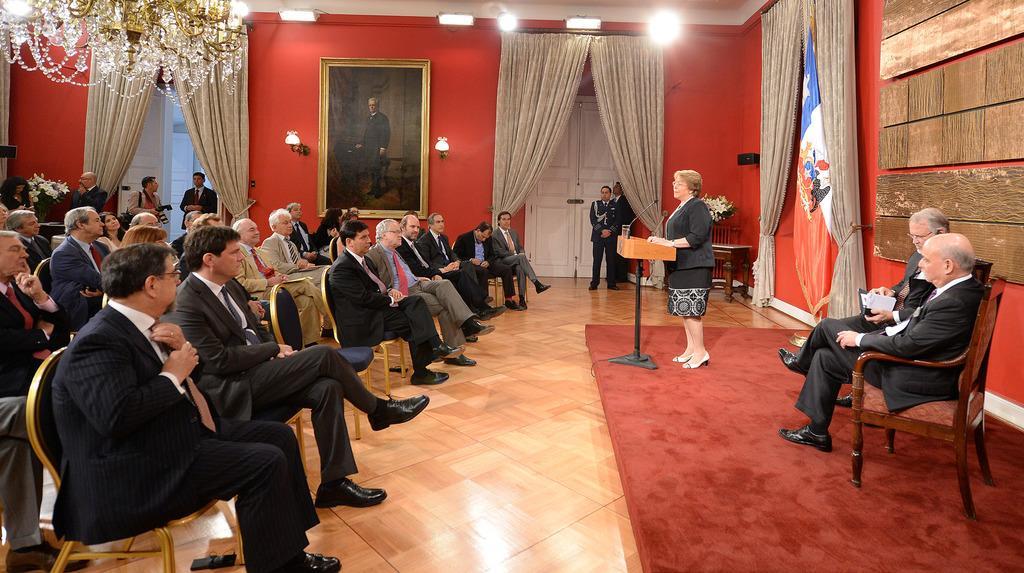Describe this image in one or two sentences. In the image we can see there are people sitting on the chair and there is a woman standing near the podium. There is a water in the glass and mic on the podium. There are curtains on the wall and there is a photo frame on the wall. There are two men sitting on the chair. 